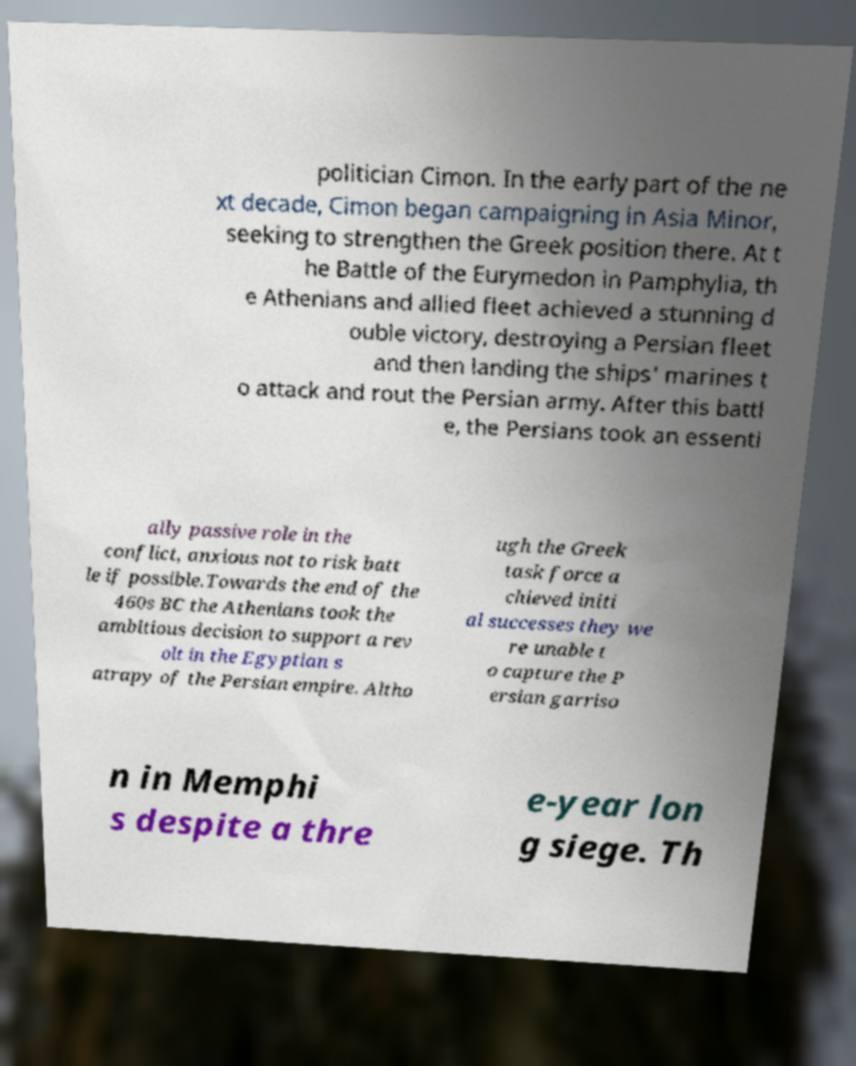Please identify and transcribe the text found in this image. politician Cimon. In the early part of the ne xt decade, Cimon began campaigning in Asia Minor, seeking to strengthen the Greek position there. At t he Battle of the Eurymedon in Pamphylia, th e Athenians and allied fleet achieved a stunning d ouble victory, destroying a Persian fleet and then landing the ships' marines t o attack and rout the Persian army. After this battl e, the Persians took an essenti ally passive role in the conflict, anxious not to risk batt le if possible.Towards the end of the 460s BC the Athenians took the ambitious decision to support a rev olt in the Egyptian s atrapy of the Persian empire. Altho ugh the Greek task force a chieved initi al successes they we re unable t o capture the P ersian garriso n in Memphi s despite a thre e-year lon g siege. Th 